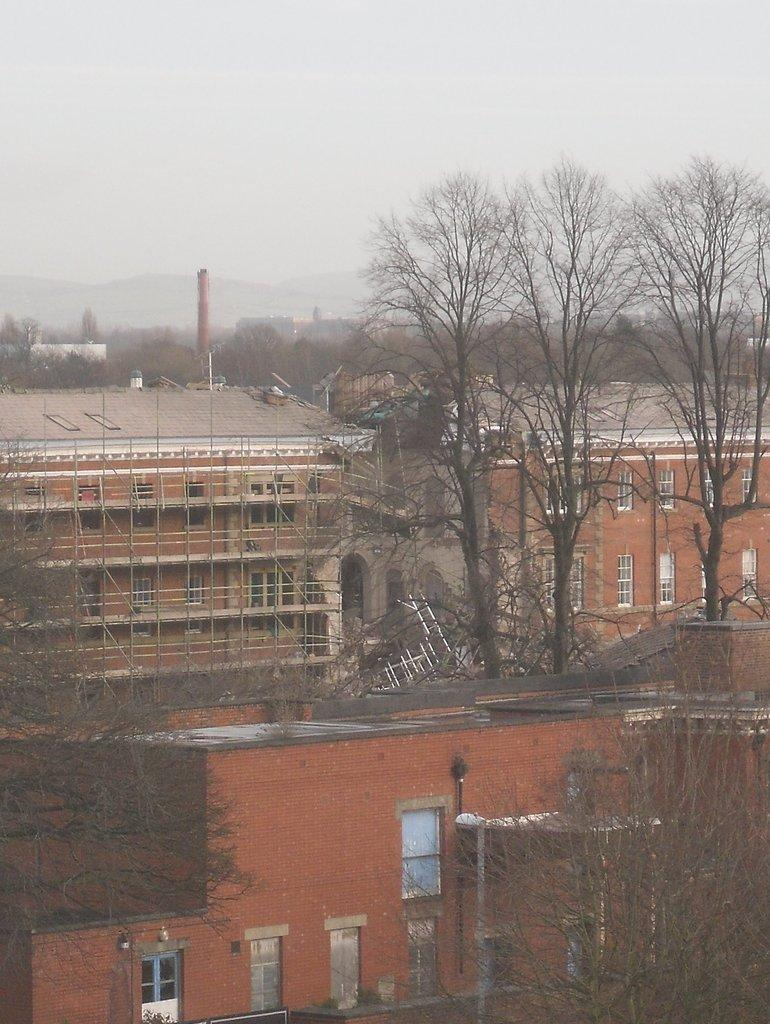What type of structures can be seen in the image? There are buildings in the image. What type of vegetation is present in the image? There are trees and plants in the image. What type of vertical structures can be seen in the image? There are poles in the image. What type of plant material is present in the image? There are bamboo sticks in the image. Can you describe any other unspecified objects in the image? Unfortunately, the provided facts do not specify any other objects in the image. What type of farming equipment is the farmer using in the image? There is no farmer present in the image, so it is not possible to answer that question. What type of container is the mother holding in the image? There is no mother or container present in the image. 